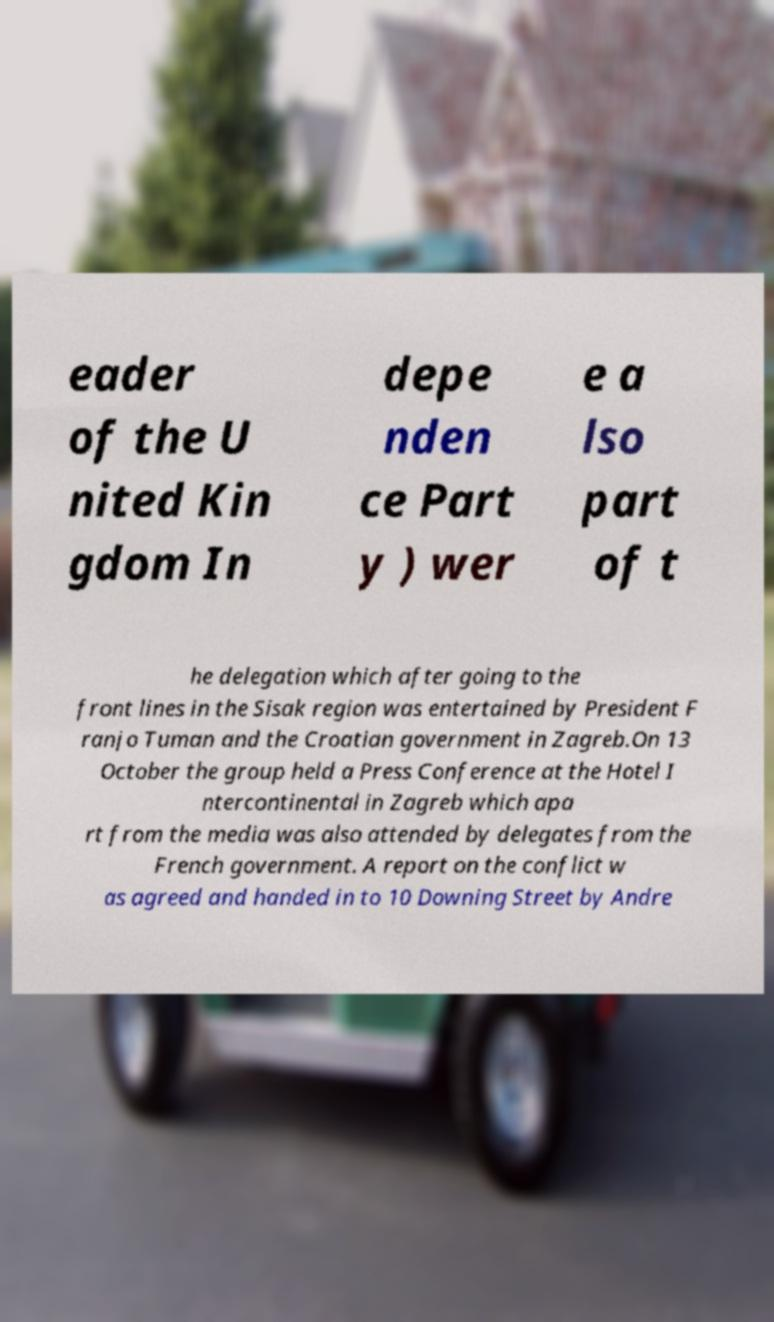Could you extract and type out the text from this image? eader of the U nited Kin gdom In depe nden ce Part y ) wer e a lso part of t he delegation which after going to the front lines in the Sisak region was entertained by President F ranjo Tuman and the Croatian government in Zagreb.On 13 October the group held a Press Conference at the Hotel I ntercontinental in Zagreb which apa rt from the media was also attended by delegates from the French government. A report on the conflict w as agreed and handed in to 10 Downing Street by Andre 